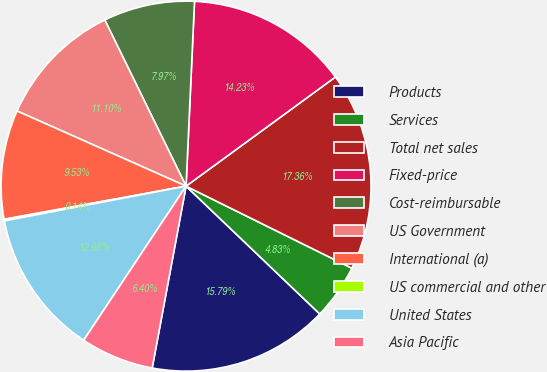Convert chart to OTSL. <chart><loc_0><loc_0><loc_500><loc_500><pie_chart><fcel>Products<fcel>Services<fcel>Total net sales<fcel>Fixed-price<fcel>Cost-reimbursable<fcel>US Government<fcel>International (a)<fcel>US commercial and other<fcel>United States<fcel>Asia Pacific<nl><fcel>15.79%<fcel>4.83%<fcel>17.36%<fcel>14.23%<fcel>7.97%<fcel>11.1%<fcel>9.53%<fcel>0.14%<fcel>12.66%<fcel>6.4%<nl></chart> 